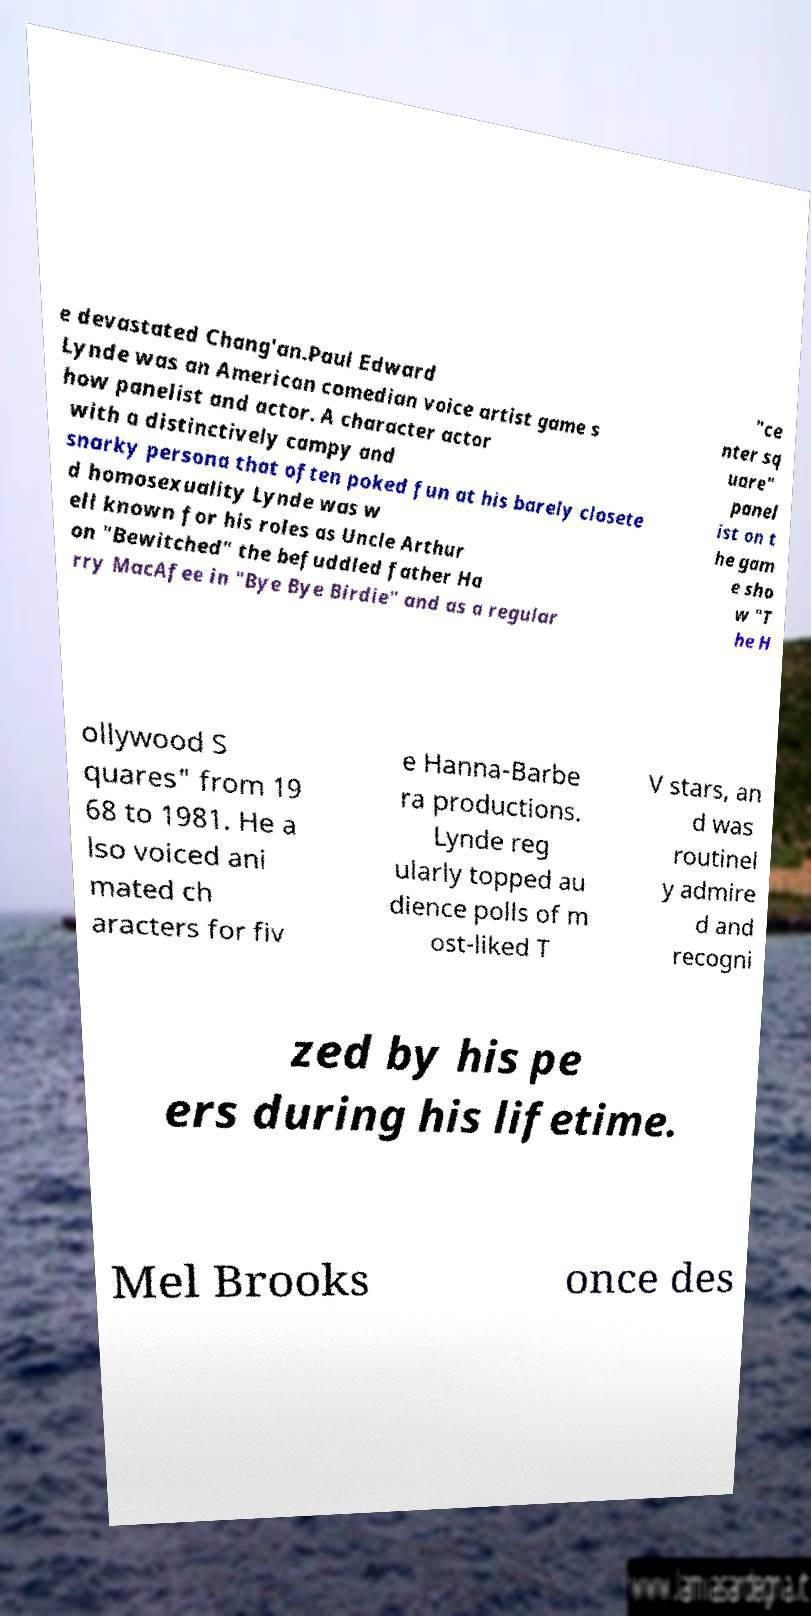For documentation purposes, I need the text within this image transcribed. Could you provide that? e devastated Chang'an.Paul Edward Lynde was an American comedian voice artist game s how panelist and actor. A character actor with a distinctively campy and snarky persona that often poked fun at his barely closete d homosexuality Lynde was w ell known for his roles as Uncle Arthur on "Bewitched" the befuddled father Ha rry MacAfee in "Bye Bye Birdie" and as a regular "ce nter sq uare" panel ist on t he gam e sho w "T he H ollywood S quares" from 19 68 to 1981. He a lso voiced ani mated ch aracters for fiv e Hanna-Barbe ra productions. Lynde reg ularly topped au dience polls of m ost-liked T V stars, an d was routinel y admire d and recogni zed by his pe ers during his lifetime. Mel Brooks once des 